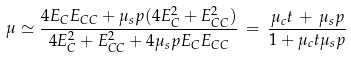Convert formula to latex. <formula><loc_0><loc_0><loc_500><loc_500>\mu \simeq \frac { 4 E _ { C } E _ { C C } + \mu _ { s } p ( 4 E _ { C } ^ { 2 } + E _ { C C } ^ { 2 } ) } { 4 E _ { C } ^ { 2 } + E _ { C C } ^ { 2 } + 4 \mu _ { s } p E _ { C } E _ { C C } } \, = \, \frac { \mu _ { c } t \, + \, \mu _ { s } p } { 1 + \mu _ { c } t \mu _ { s } p }</formula> 